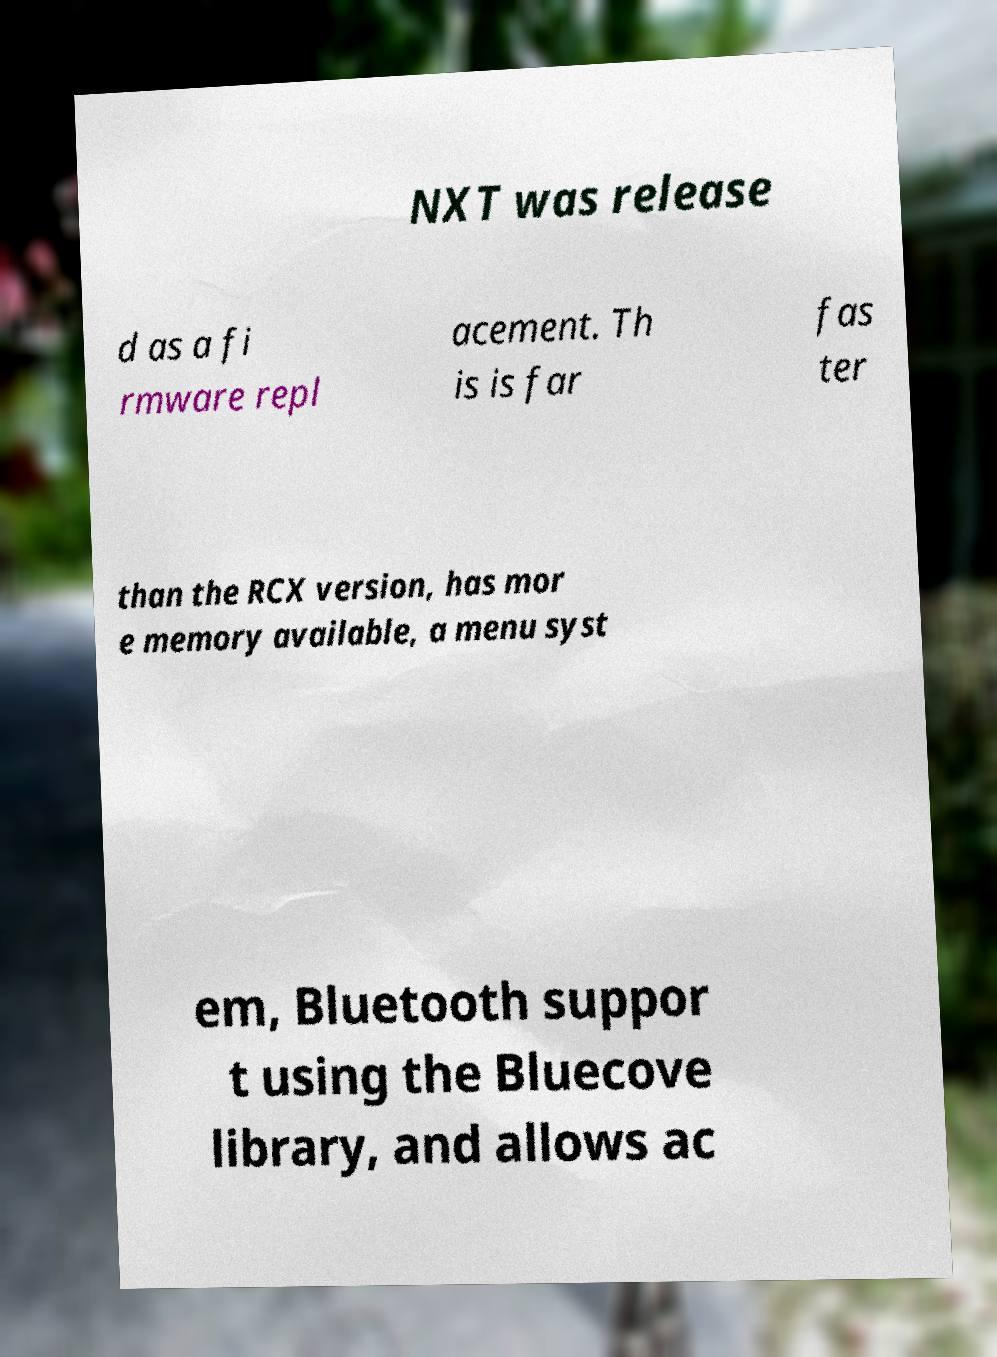Please read and relay the text visible in this image. What does it say? NXT was release d as a fi rmware repl acement. Th is is far fas ter than the RCX version, has mor e memory available, a menu syst em, Bluetooth suppor t using the Bluecove library, and allows ac 